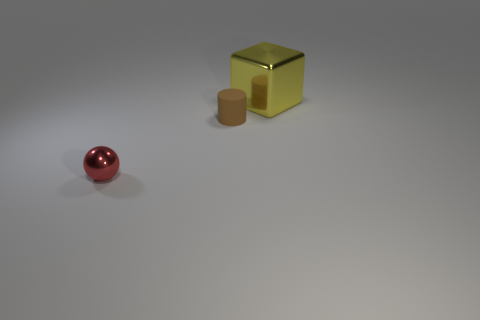Add 3 big brown metal spheres. How many objects exist? 6 Subtract all cylinders. How many objects are left? 2 Subtract all small matte cylinders. Subtract all yellow shiny objects. How many objects are left? 1 Add 1 metal spheres. How many metal spheres are left? 2 Add 1 large blue cylinders. How many large blue cylinders exist? 1 Subtract 0 purple spheres. How many objects are left? 3 